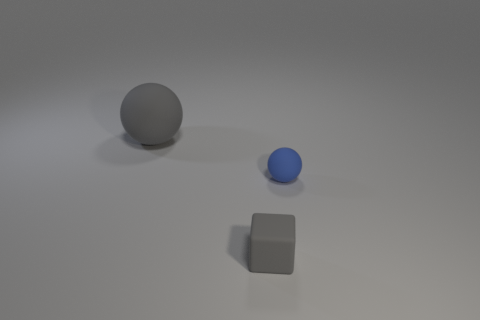What number of objects are big balls that are behind the tiny gray matte object or gray blocks?
Your response must be concise. 2. Does the rubber ball that is to the right of the large ball have the same color as the rubber cube?
Provide a succinct answer. No. What number of other things are the same color as the small rubber sphere?
Make the answer very short. 0. How many large things are matte cubes or matte balls?
Ensure brevity in your answer.  1. Is the number of small rubber things greater than the number of small yellow rubber cubes?
Give a very brief answer. Yes. Are the big gray object and the tiny blue ball made of the same material?
Provide a short and direct response. Yes. Is the number of large gray balls that are to the left of the small matte ball greater than the number of brown rubber cylinders?
Ensure brevity in your answer.  Yes. Is the color of the small matte cube the same as the large matte sphere?
Offer a terse response. Yes. What number of other blue objects are the same shape as the large rubber object?
Provide a short and direct response. 1. The cube that is made of the same material as the gray ball is what size?
Keep it short and to the point. Small. 